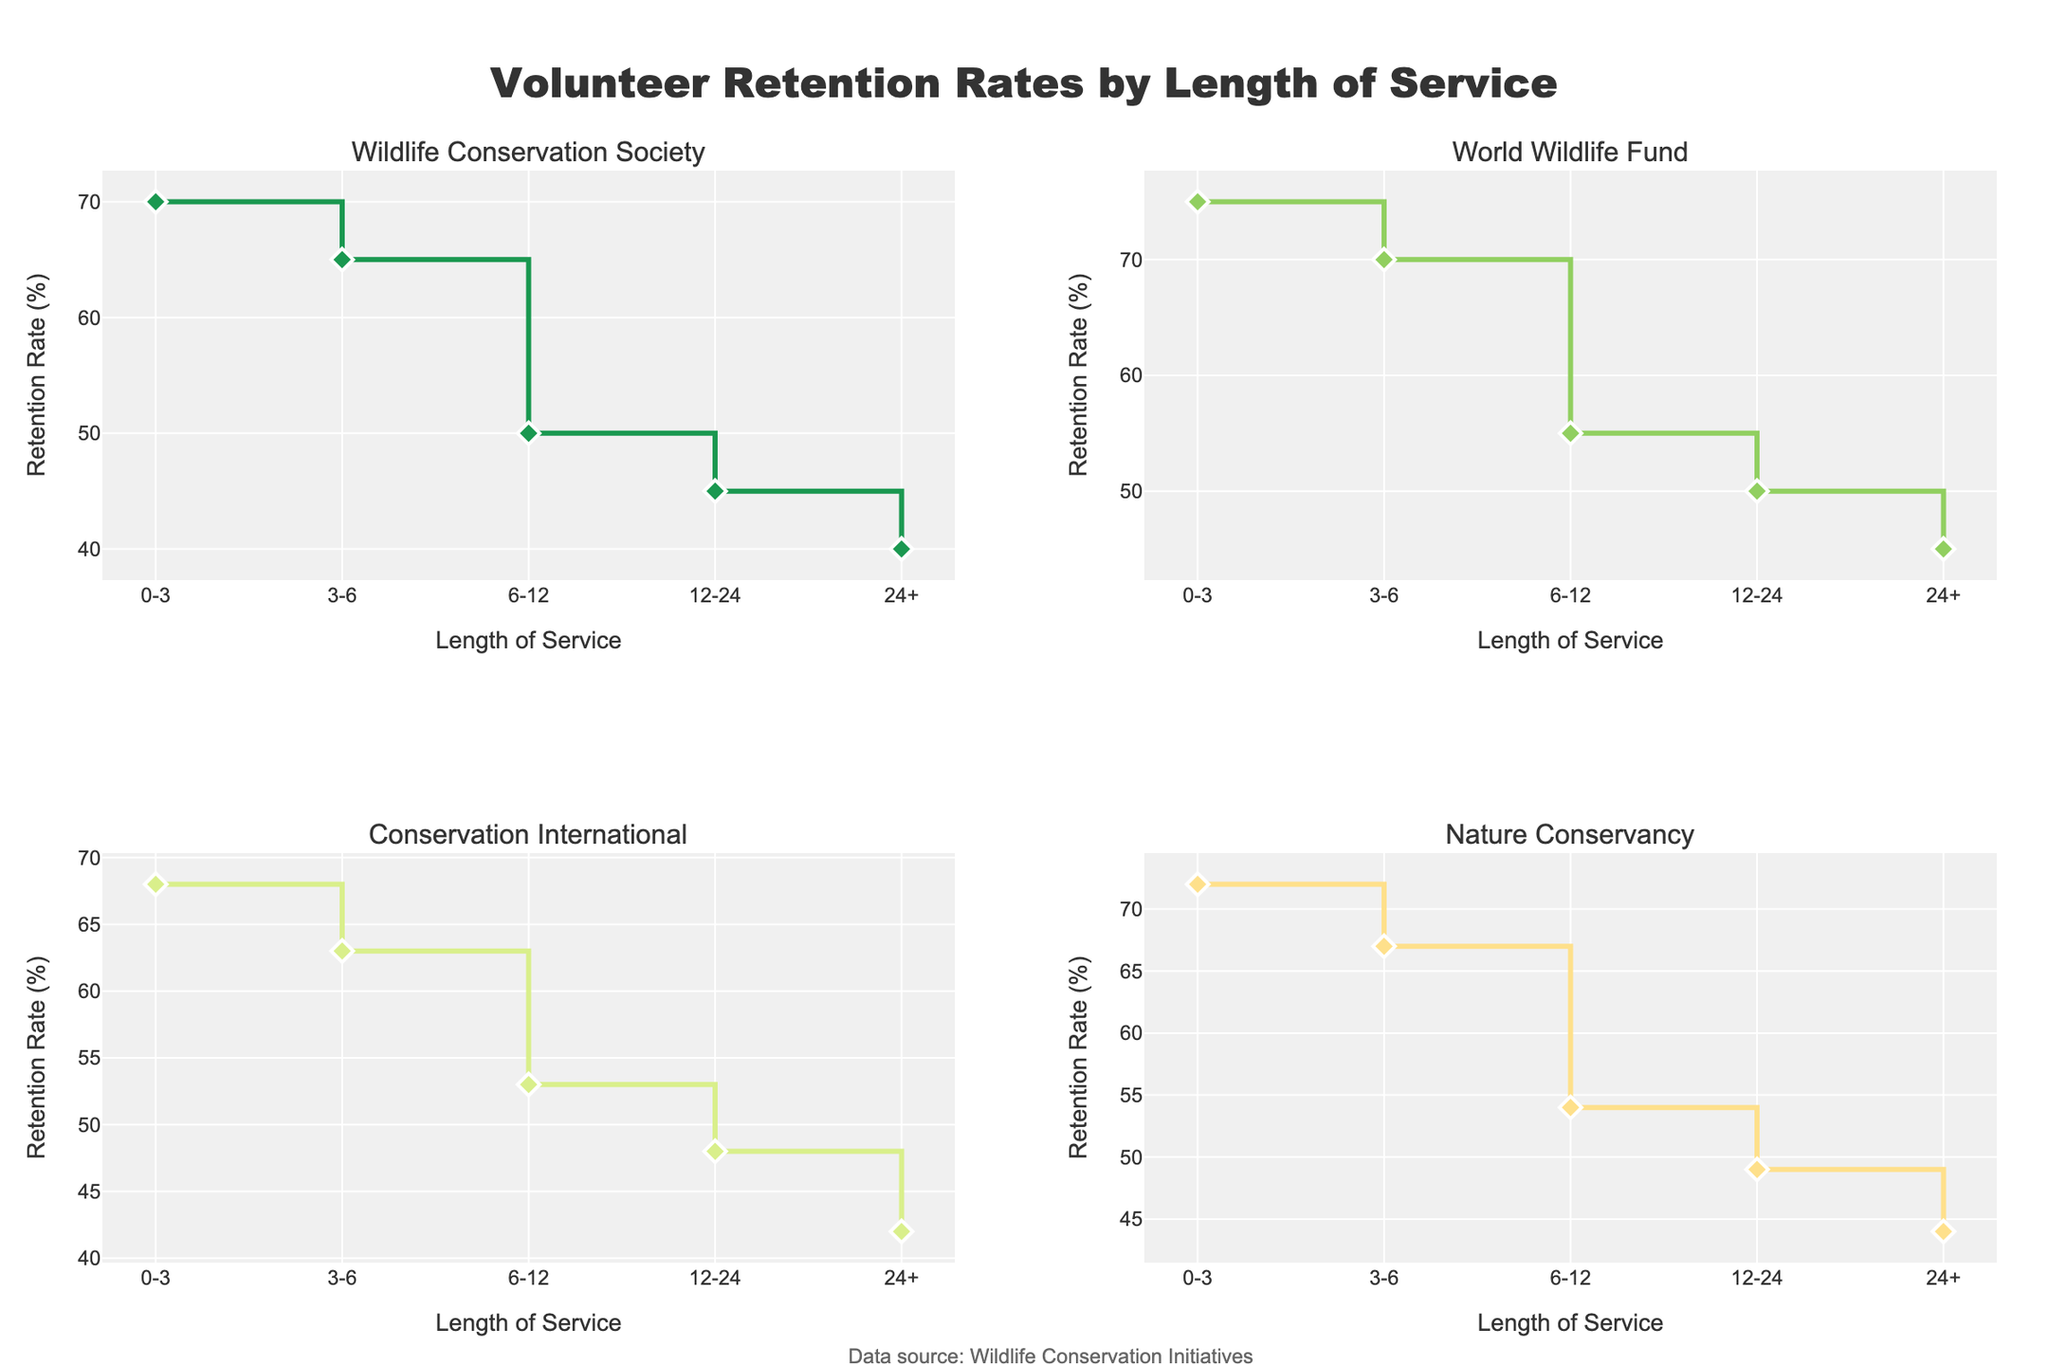How many organizations are represented in the figure? From the figure, there are four distinct subplots, each indicating a different organization: Wildlife Conservation Society, World Wildlife Fund, Conservation International, and Nature Conservancy.
Answer: 4 What is the retention rate for the 24+ months category for the Wildlife Conservation Society? Locate the subplot for the Wildlife Conservation Society and find the retention rate at the "24+" months category. It shows 40%.
Answer: 40% Compare the retention rate for the 0-3 months category between Wildlife Conservation Society and World Wildlife Fund. Which organization has a higher rate? The subplot for Wildlife Conservation Society shows a retention rate of 70% for the 0-3 months category, whereas the World Wildlife Fund shows 75%. 75% is higher than 70%.
Answer: World Wildlife Fund What is the average retention rate for Conservation International across all categories? The retention rates for Conservation International are 68%, 63%, 53%, 48%, and 42%. The sum of these values is 274. Dividing by the 5 categories gives an average of 54.8%.
Answer: 54.8% Which organization exhibits the highest retention rate for the 12-24 months category? Compare the retention rates in the "12-24" months category across all subplots: Wildlife Conservation Society (45%), World Wildlife Fund (50%), Conservation International (48%), and Nature Conservancy (49%). The highest rate is 50% by the World Wildlife Fund.
Answer: World Wildlife Fund Does any organization have a retention rate that increases as the length of service increases? Examine each subplot carefully. All organizations show a decreasing trend in retention rates as the length of service increases.
Answer: No What is the difference in retention rates for the 6-12 months category between Nature Conservancy and Conservation International? The retention rate for Nature Conservancy in the 6-12 months category is 54%, and for Conservation International, it is 53%. The difference is 54% - 53% = 1%.
Answer: 1% For the World Wildlife Fund, what is the trend in retention rates as the length of service increases? In the World Wildlife Fund subplot, the retention rates decrease from 75% (0-3 months) to 45% (24+ months). This shows a downward trend.
Answer: Decreasing Which organization has the most significant drop in retention rate between the 0-3 months and 6-12 months categories? Calculate the difference in retention rates for the 0-3 and 6-12 months categories for each organization: Wildlife Conservation Society (70% to 50% = 20%), World Wildlife Fund (75% to 55% = 20%), Conservation International (68% to 53% = 15%), Nature Conservancy (72% to 54% = 18%). Both Wildlife Conservation Society and World Wildlife Fund have the most significant drop of 20%.
Answer: Wildlife Conservation Society and World Wildlife Fund 